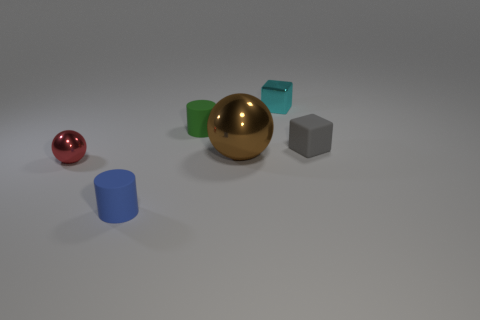Add 1 small blue cylinders. How many objects exist? 7 Subtract all cylinders. How many objects are left? 4 Add 3 tiny blue rubber blocks. How many tiny blue rubber blocks exist? 3 Subtract 1 gray blocks. How many objects are left? 5 Subtract all blue metallic things. Subtract all small green things. How many objects are left? 5 Add 4 blue things. How many blue things are left? 5 